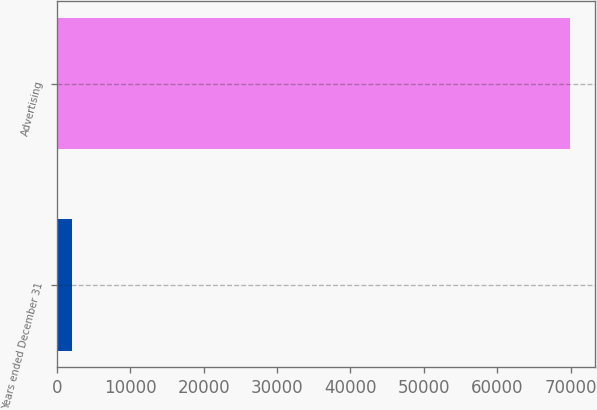Convert chart. <chart><loc_0><loc_0><loc_500><loc_500><bar_chart><fcel>Years ended December 31<fcel>Advertising<nl><fcel>2018<fcel>69875<nl></chart> 